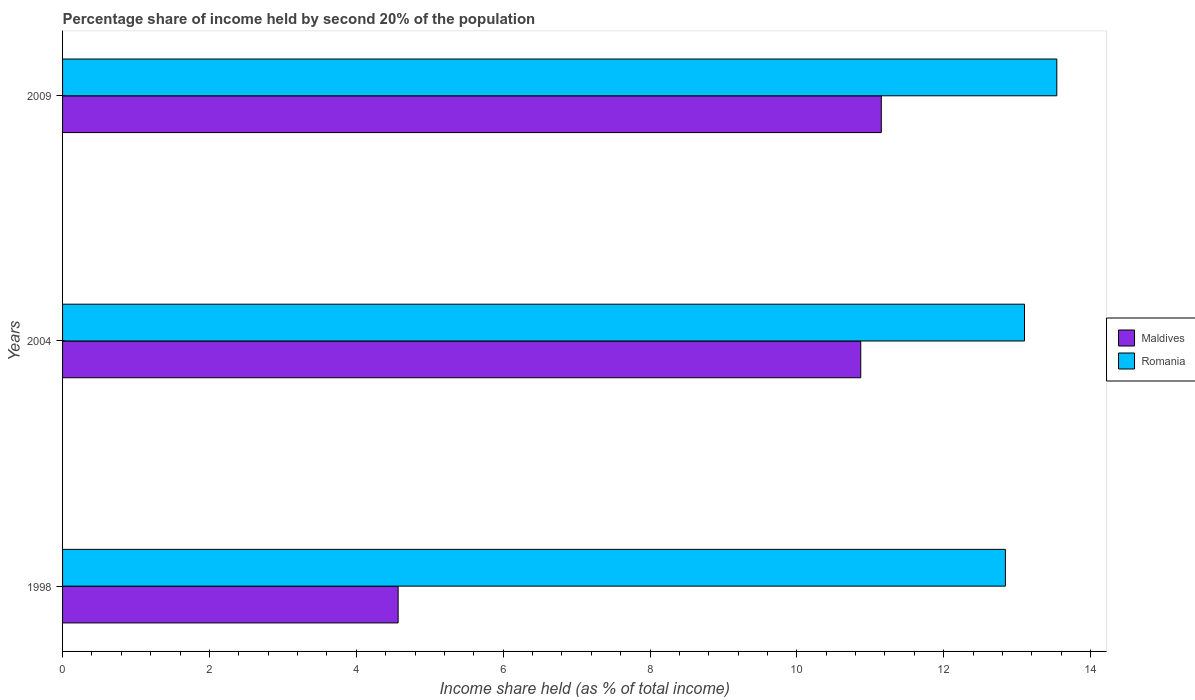How many different coloured bars are there?
Provide a succinct answer. 2. How many groups of bars are there?
Provide a succinct answer. 3. Are the number of bars on each tick of the Y-axis equal?
Your response must be concise. Yes. How many bars are there on the 2nd tick from the top?
Provide a succinct answer. 2. How many bars are there on the 1st tick from the bottom?
Provide a succinct answer. 2. What is the label of the 1st group of bars from the top?
Your answer should be very brief. 2009. In how many cases, is the number of bars for a given year not equal to the number of legend labels?
Your answer should be very brief. 0. What is the share of income held by second 20% of the population in Maldives in 1998?
Provide a short and direct response. 4.57. Across all years, what is the maximum share of income held by second 20% of the population in Romania?
Your response must be concise. 13.54. Across all years, what is the minimum share of income held by second 20% of the population in Romania?
Give a very brief answer. 12.84. What is the total share of income held by second 20% of the population in Romania in the graph?
Make the answer very short. 39.48. What is the difference between the share of income held by second 20% of the population in Maldives in 1998 and that in 2009?
Provide a short and direct response. -6.58. What is the difference between the share of income held by second 20% of the population in Maldives in 2004 and the share of income held by second 20% of the population in Romania in 2009?
Keep it short and to the point. -2.67. What is the average share of income held by second 20% of the population in Romania per year?
Provide a succinct answer. 13.16. In the year 1998, what is the difference between the share of income held by second 20% of the population in Romania and share of income held by second 20% of the population in Maldives?
Provide a succinct answer. 8.27. What is the ratio of the share of income held by second 20% of the population in Romania in 1998 to that in 2009?
Provide a succinct answer. 0.95. Is the share of income held by second 20% of the population in Maldives in 1998 less than that in 2009?
Give a very brief answer. Yes. Is the difference between the share of income held by second 20% of the population in Romania in 1998 and 2009 greater than the difference between the share of income held by second 20% of the population in Maldives in 1998 and 2009?
Give a very brief answer. Yes. What is the difference between the highest and the second highest share of income held by second 20% of the population in Romania?
Give a very brief answer. 0.44. What is the difference between the highest and the lowest share of income held by second 20% of the population in Romania?
Offer a very short reply. 0.7. In how many years, is the share of income held by second 20% of the population in Romania greater than the average share of income held by second 20% of the population in Romania taken over all years?
Provide a succinct answer. 1. Is the sum of the share of income held by second 20% of the population in Maldives in 2004 and 2009 greater than the maximum share of income held by second 20% of the population in Romania across all years?
Make the answer very short. Yes. What does the 2nd bar from the top in 2009 represents?
Offer a very short reply. Maldives. What does the 1st bar from the bottom in 1998 represents?
Your answer should be very brief. Maldives. Are all the bars in the graph horizontal?
Offer a terse response. Yes. What is the difference between two consecutive major ticks on the X-axis?
Provide a short and direct response. 2. Are the values on the major ticks of X-axis written in scientific E-notation?
Provide a short and direct response. No. Does the graph contain grids?
Provide a succinct answer. No. How many legend labels are there?
Provide a succinct answer. 2. What is the title of the graph?
Your answer should be compact. Percentage share of income held by second 20% of the population. Does "Seychelles" appear as one of the legend labels in the graph?
Ensure brevity in your answer.  No. What is the label or title of the X-axis?
Make the answer very short. Income share held (as % of total income). What is the label or title of the Y-axis?
Your answer should be very brief. Years. What is the Income share held (as % of total income) in Maldives in 1998?
Keep it short and to the point. 4.57. What is the Income share held (as % of total income) in Romania in 1998?
Ensure brevity in your answer.  12.84. What is the Income share held (as % of total income) in Maldives in 2004?
Ensure brevity in your answer.  10.87. What is the Income share held (as % of total income) of Maldives in 2009?
Offer a very short reply. 11.15. What is the Income share held (as % of total income) of Romania in 2009?
Provide a succinct answer. 13.54. Across all years, what is the maximum Income share held (as % of total income) of Maldives?
Keep it short and to the point. 11.15. Across all years, what is the maximum Income share held (as % of total income) of Romania?
Ensure brevity in your answer.  13.54. Across all years, what is the minimum Income share held (as % of total income) of Maldives?
Make the answer very short. 4.57. Across all years, what is the minimum Income share held (as % of total income) of Romania?
Your response must be concise. 12.84. What is the total Income share held (as % of total income) of Maldives in the graph?
Your response must be concise. 26.59. What is the total Income share held (as % of total income) of Romania in the graph?
Your answer should be very brief. 39.48. What is the difference between the Income share held (as % of total income) in Maldives in 1998 and that in 2004?
Keep it short and to the point. -6.3. What is the difference between the Income share held (as % of total income) in Romania in 1998 and that in 2004?
Give a very brief answer. -0.26. What is the difference between the Income share held (as % of total income) in Maldives in 1998 and that in 2009?
Your answer should be compact. -6.58. What is the difference between the Income share held (as % of total income) in Maldives in 2004 and that in 2009?
Keep it short and to the point. -0.28. What is the difference between the Income share held (as % of total income) in Romania in 2004 and that in 2009?
Provide a succinct answer. -0.44. What is the difference between the Income share held (as % of total income) of Maldives in 1998 and the Income share held (as % of total income) of Romania in 2004?
Provide a succinct answer. -8.53. What is the difference between the Income share held (as % of total income) in Maldives in 1998 and the Income share held (as % of total income) in Romania in 2009?
Provide a succinct answer. -8.97. What is the difference between the Income share held (as % of total income) in Maldives in 2004 and the Income share held (as % of total income) in Romania in 2009?
Keep it short and to the point. -2.67. What is the average Income share held (as % of total income) in Maldives per year?
Offer a very short reply. 8.86. What is the average Income share held (as % of total income) in Romania per year?
Give a very brief answer. 13.16. In the year 1998, what is the difference between the Income share held (as % of total income) of Maldives and Income share held (as % of total income) of Romania?
Keep it short and to the point. -8.27. In the year 2004, what is the difference between the Income share held (as % of total income) of Maldives and Income share held (as % of total income) of Romania?
Offer a very short reply. -2.23. In the year 2009, what is the difference between the Income share held (as % of total income) in Maldives and Income share held (as % of total income) in Romania?
Your answer should be compact. -2.39. What is the ratio of the Income share held (as % of total income) of Maldives in 1998 to that in 2004?
Offer a very short reply. 0.42. What is the ratio of the Income share held (as % of total income) of Romania in 1998 to that in 2004?
Offer a terse response. 0.98. What is the ratio of the Income share held (as % of total income) in Maldives in 1998 to that in 2009?
Make the answer very short. 0.41. What is the ratio of the Income share held (as % of total income) of Romania in 1998 to that in 2009?
Your response must be concise. 0.95. What is the ratio of the Income share held (as % of total income) in Maldives in 2004 to that in 2009?
Provide a short and direct response. 0.97. What is the ratio of the Income share held (as % of total income) of Romania in 2004 to that in 2009?
Your answer should be very brief. 0.97. What is the difference between the highest and the second highest Income share held (as % of total income) in Maldives?
Your answer should be very brief. 0.28. What is the difference between the highest and the second highest Income share held (as % of total income) of Romania?
Offer a terse response. 0.44. What is the difference between the highest and the lowest Income share held (as % of total income) in Maldives?
Give a very brief answer. 6.58. What is the difference between the highest and the lowest Income share held (as % of total income) of Romania?
Your answer should be very brief. 0.7. 